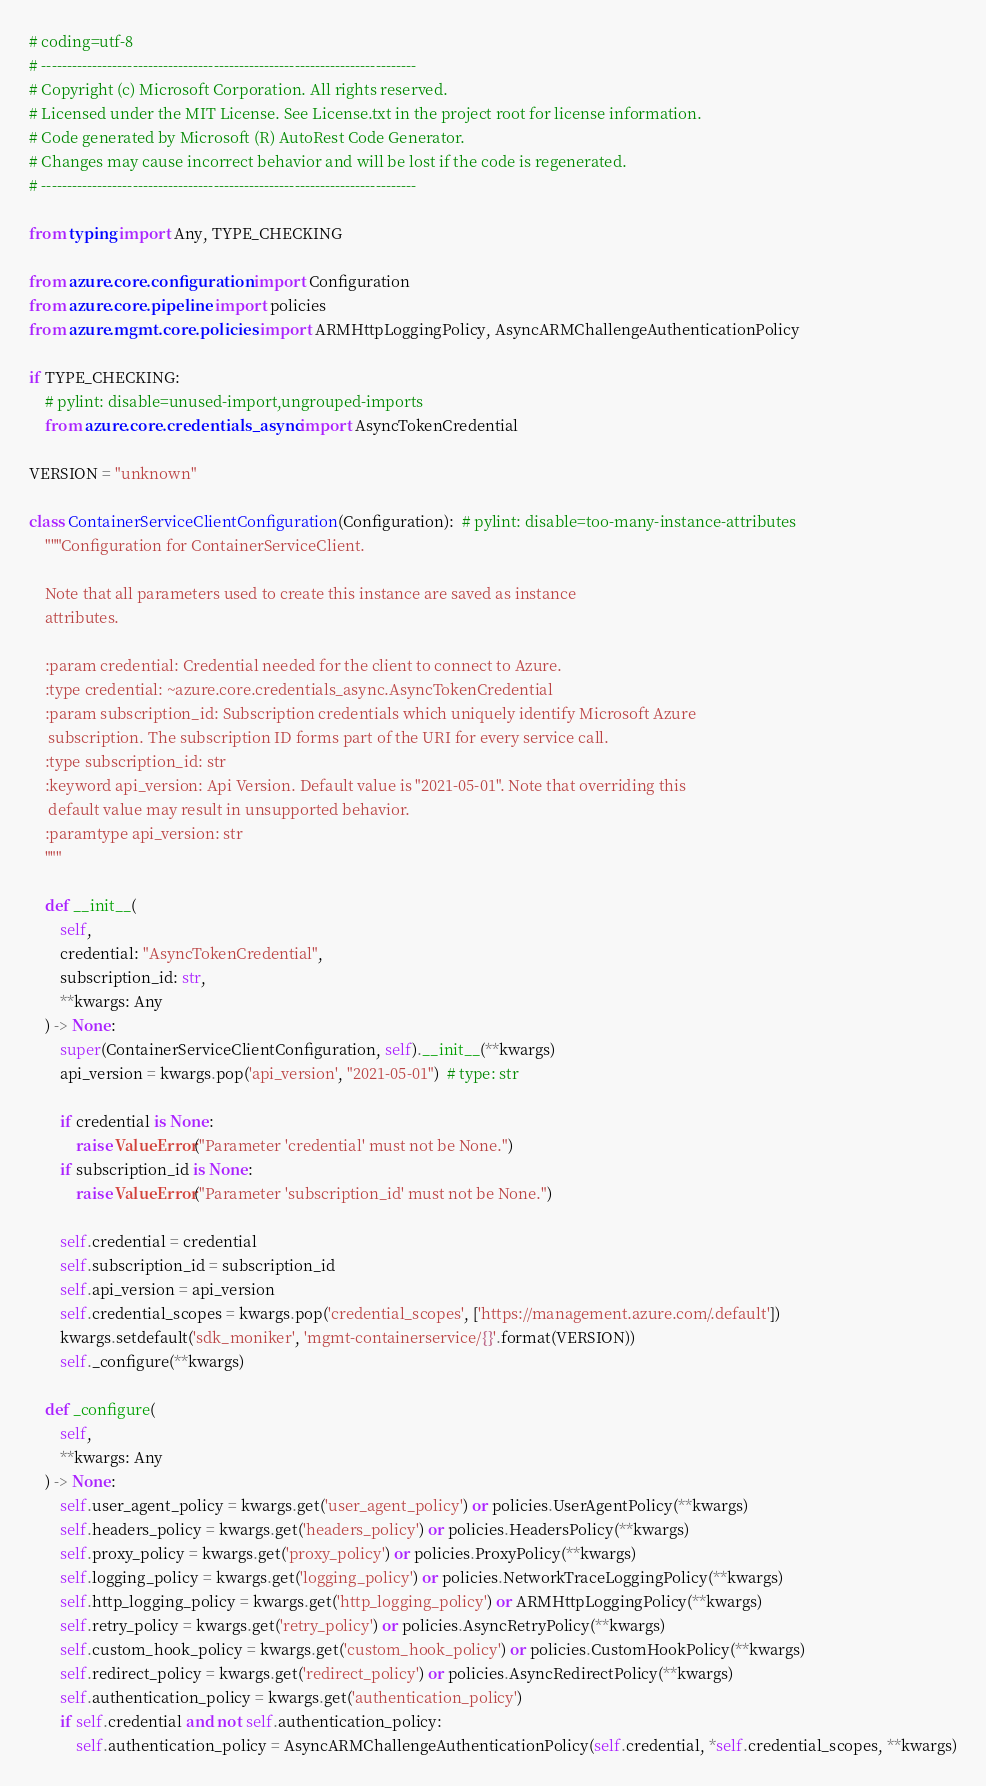Convert code to text. <code><loc_0><loc_0><loc_500><loc_500><_Python_># coding=utf-8
# --------------------------------------------------------------------------
# Copyright (c) Microsoft Corporation. All rights reserved.
# Licensed under the MIT License. See License.txt in the project root for license information.
# Code generated by Microsoft (R) AutoRest Code Generator.
# Changes may cause incorrect behavior and will be lost if the code is regenerated.
# --------------------------------------------------------------------------

from typing import Any, TYPE_CHECKING

from azure.core.configuration import Configuration
from azure.core.pipeline import policies
from azure.mgmt.core.policies import ARMHttpLoggingPolicy, AsyncARMChallengeAuthenticationPolicy

if TYPE_CHECKING:
    # pylint: disable=unused-import,ungrouped-imports
    from azure.core.credentials_async import AsyncTokenCredential

VERSION = "unknown"

class ContainerServiceClientConfiguration(Configuration):  # pylint: disable=too-many-instance-attributes
    """Configuration for ContainerServiceClient.

    Note that all parameters used to create this instance are saved as instance
    attributes.

    :param credential: Credential needed for the client to connect to Azure.
    :type credential: ~azure.core.credentials_async.AsyncTokenCredential
    :param subscription_id: Subscription credentials which uniquely identify Microsoft Azure
     subscription. The subscription ID forms part of the URI for every service call.
    :type subscription_id: str
    :keyword api_version: Api Version. Default value is "2021-05-01". Note that overriding this
     default value may result in unsupported behavior.
    :paramtype api_version: str
    """

    def __init__(
        self,
        credential: "AsyncTokenCredential",
        subscription_id: str,
        **kwargs: Any
    ) -> None:
        super(ContainerServiceClientConfiguration, self).__init__(**kwargs)
        api_version = kwargs.pop('api_version', "2021-05-01")  # type: str

        if credential is None:
            raise ValueError("Parameter 'credential' must not be None.")
        if subscription_id is None:
            raise ValueError("Parameter 'subscription_id' must not be None.")

        self.credential = credential
        self.subscription_id = subscription_id
        self.api_version = api_version
        self.credential_scopes = kwargs.pop('credential_scopes', ['https://management.azure.com/.default'])
        kwargs.setdefault('sdk_moniker', 'mgmt-containerservice/{}'.format(VERSION))
        self._configure(**kwargs)

    def _configure(
        self,
        **kwargs: Any
    ) -> None:
        self.user_agent_policy = kwargs.get('user_agent_policy') or policies.UserAgentPolicy(**kwargs)
        self.headers_policy = kwargs.get('headers_policy') or policies.HeadersPolicy(**kwargs)
        self.proxy_policy = kwargs.get('proxy_policy') or policies.ProxyPolicy(**kwargs)
        self.logging_policy = kwargs.get('logging_policy') or policies.NetworkTraceLoggingPolicy(**kwargs)
        self.http_logging_policy = kwargs.get('http_logging_policy') or ARMHttpLoggingPolicy(**kwargs)
        self.retry_policy = kwargs.get('retry_policy') or policies.AsyncRetryPolicy(**kwargs)
        self.custom_hook_policy = kwargs.get('custom_hook_policy') or policies.CustomHookPolicy(**kwargs)
        self.redirect_policy = kwargs.get('redirect_policy') or policies.AsyncRedirectPolicy(**kwargs)
        self.authentication_policy = kwargs.get('authentication_policy')
        if self.credential and not self.authentication_policy:
            self.authentication_policy = AsyncARMChallengeAuthenticationPolicy(self.credential, *self.credential_scopes, **kwargs)
</code> 